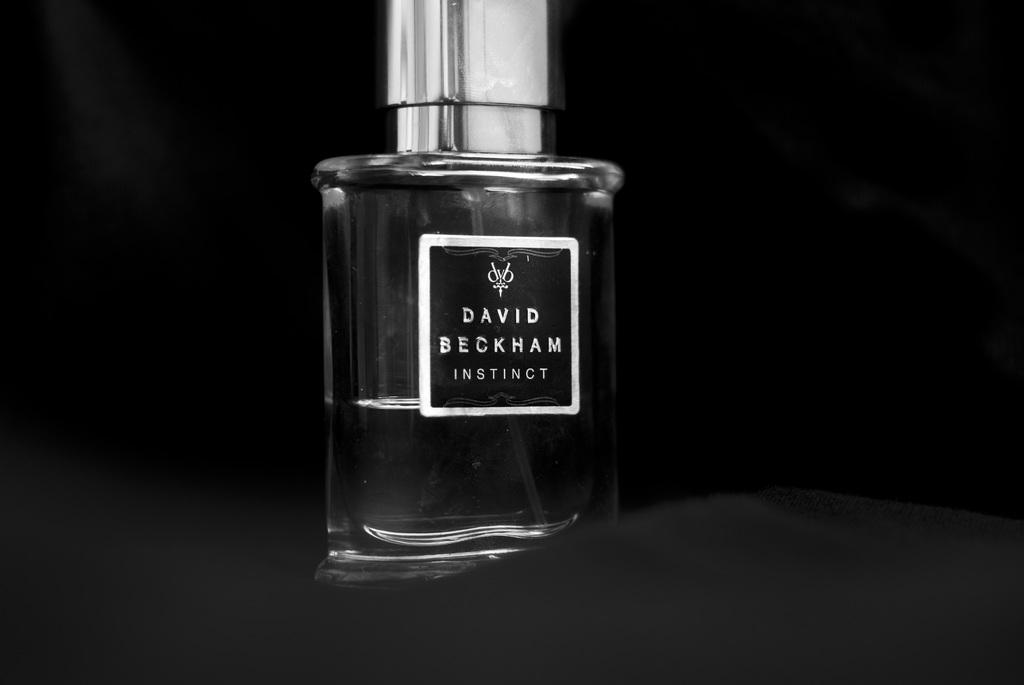<image>
Describe the image concisely. A small bottle of David Beckham's Instict sits on a black counter. 